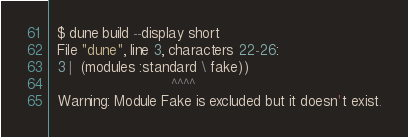<code> <loc_0><loc_0><loc_500><loc_500><_Perl_>  $ dune build --display short
  File "dune", line 3, characters 22-26:
  3 |  (modules :standard \ fake))
                            ^^^^
  Warning: Module Fake is excluded but it doesn't exist.
</code> 